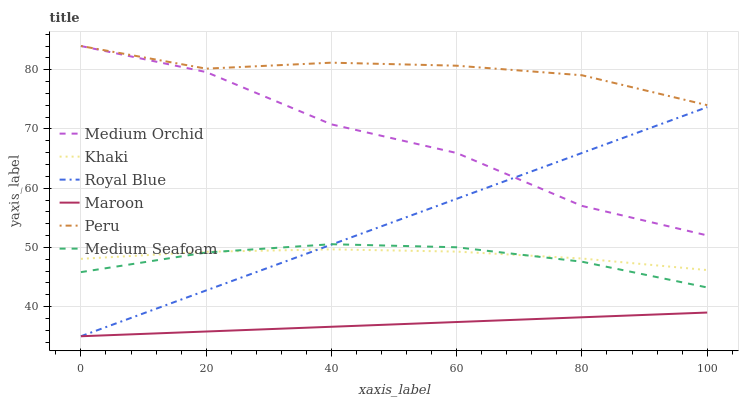Does Maroon have the minimum area under the curve?
Answer yes or no. Yes. Does Peru have the maximum area under the curve?
Answer yes or no. Yes. Does Medium Orchid have the minimum area under the curve?
Answer yes or no. No. Does Medium Orchid have the maximum area under the curve?
Answer yes or no. No. Is Maroon the smoothest?
Answer yes or no. Yes. Is Medium Orchid the roughest?
Answer yes or no. Yes. Is Medium Orchid the smoothest?
Answer yes or no. No. Is Maroon the roughest?
Answer yes or no. No. Does Medium Orchid have the lowest value?
Answer yes or no. No. Does Peru have the highest value?
Answer yes or no. Yes. Does Maroon have the highest value?
Answer yes or no. No. Is Maroon less than Medium Orchid?
Answer yes or no. Yes. Is Medium Orchid greater than Khaki?
Answer yes or no. Yes. Does Medium Seafoam intersect Royal Blue?
Answer yes or no. Yes. Is Medium Seafoam less than Royal Blue?
Answer yes or no. No. Is Medium Seafoam greater than Royal Blue?
Answer yes or no. No. Does Maroon intersect Medium Orchid?
Answer yes or no. No. 